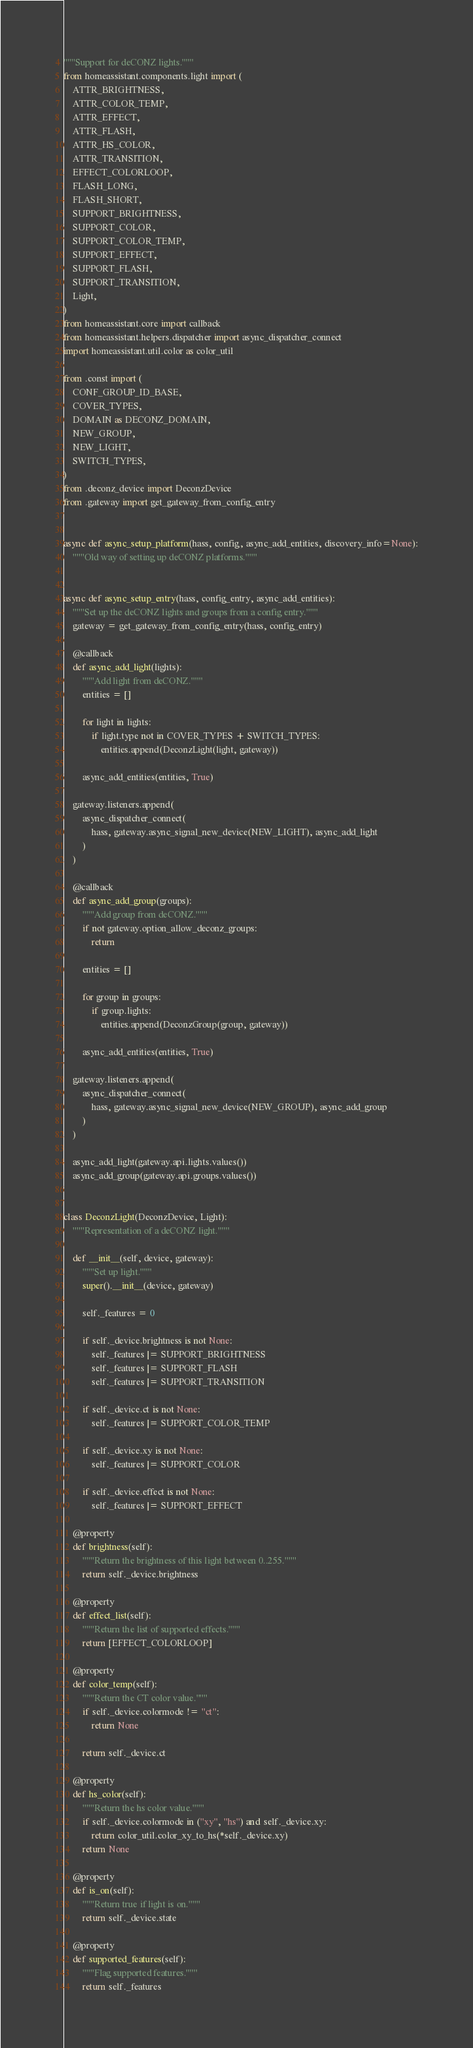<code> <loc_0><loc_0><loc_500><loc_500><_Python_>"""Support for deCONZ lights."""
from homeassistant.components.light import (
    ATTR_BRIGHTNESS,
    ATTR_COLOR_TEMP,
    ATTR_EFFECT,
    ATTR_FLASH,
    ATTR_HS_COLOR,
    ATTR_TRANSITION,
    EFFECT_COLORLOOP,
    FLASH_LONG,
    FLASH_SHORT,
    SUPPORT_BRIGHTNESS,
    SUPPORT_COLOR,
    SUPPORT_COLOR_TEMP,
    SUPPORT_EFFECT,
    SUPPORT_FLASH,
    SUPPORT_TRANSITION,
    Light,
)
from homeassistant.core import callback
from homeassistant.helpers.dispatcher import async_dispatcher_connect
import homeassistant.util.color as color_util

from .const import (
    CONF_GROUP_ID_BASE,
    COVER_TYPES,
    DOMAIN as DECONZ_DOMAIN,
    NEW_GROUP,
    NEW_LIGHT,
    SWITCH_TYPES,
)
from .deconz_device import DeconzDevice
from .gateway import get_gateway_from_config_entry


async def async_setup_platform(hass, config, async_add_entities, discovery_info=None):
    """Old way of setting up deCONZ platforms."""


async def async_setup_entry(hass, config_entry, async_add_entities):
    """Set up the deCONZ lights and groups from a config entry."""
    gateway = get_gateway_from_config_entry(hass, config_entry)

    @callback
    def async_add_light(lights):
        """Add light from deCONZ."""
        entities = []

        for light in lights:
            if light.type not in COVER_TYPES + SWITCH_TYPES:
                entities.append(DeconzLight(light, gateway))

        async_add_entities(entities, True)

    gateway.listeners.append(
        async_dispatcher_connect(
            hass, gateway.async_signal_new_device(NEW_LIGHT), async_add_light
        )
    )

    @callback
    def async_add_group(groups):
        """Add group from deCONZ."""
        if not gateway.option_allow_deconz_groups:
            return

        entities = []

        for group in groups:
            if group.lights:
                entities.append(DeconzGroup(group, gateway))

        async_add_entities(entities, True)

    gateway.listeners.append(
        async_dispatcher_connect(
            hass, gateway.async_signal_new_device(NEW_GROUP), async_add_group
        )
    )

    async_add_light(gateway.api.lights.values())
    async_add_group(gateway.api.groups.values())


class DeconzLight(DeconzDevice, Light):
    """Representation of a deCONZ light."""

    def __init__(self, device, gateway):
        """Set up light."""
        super().__init__(device, gateway)

        self._features = 0

        if self._device.brightness is not None:
            self._features |= SUPPORT_BRIGHTNESS
            self._features |= SUPPORT_FLASH
            self._features |= SUPPORT_TRANSITION

        if self._device.ct is not None:
            self._features |= SUPPORT_COLOR_TEMP

        if self._device.xy is not None:
            self._features |= SUPPORT_COLOR

        if self._device.effect is not None:
            self._features |= SUPPORT_EFFECT

    @property
    def brightness(self):
        """Return the brightness of this light between 0..255."""
        return self._device.brightness

    @property
    def effect_list(self):
        """Return the list of supported effects."""
        return [EFFECT_COLORLOOP]

    @property
    def color_temp(self):
        """Return the CT color value."""
        if self._device.colormode != "ct":
            return None

        return self._device.ct

    @property
    def hs_color(self):
        """Return the hs color value."""
        if self._device.colormode in ("xy", "hs") and self._device.xy:
            return color_util.color_xy_to_hs(*self._device.xy)
        return None

    @property
    def is_on(self):
        """Return true if light is on."""
        return self._device.state

    @property
    def supported_features(self):
        """Flag supported features."""
        return self._features
</code> 